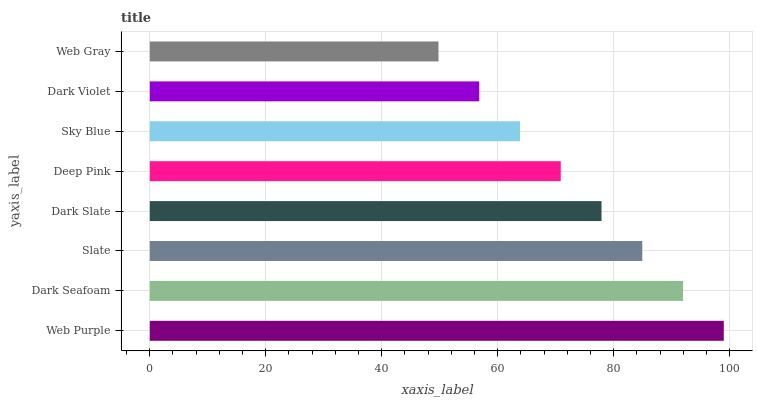Is Web Gray the minimum?
Answer yes or no. Yes. Is Web Purple the maximum?
Answer yes or no. Yes. Is Dark Seafoam the minimum?
Answer yes or no. No. Is Dark Seafoam the maximum?
Answer yes or no. No. Is Web Purple greater than Dark Seafoam?
Answer yes or no. Yes. Is Dark Seafoam less than Web Purple?
Answer yes or no. Yes. Is Dark Seafoam greater than Web Purple?
Answer yes or no. No. Is Web Purple less than Dark Seafoam?
Answer yes or no. No. Is Dark Slate the high median?
Answer yes or no. Yes. Is Deep Pink the low median?
Answer yes or no. Yes. Is Slate the high median?
Answer yes or no. No. Is Dark Seafoam the low median?
Answer yes or no. No. 